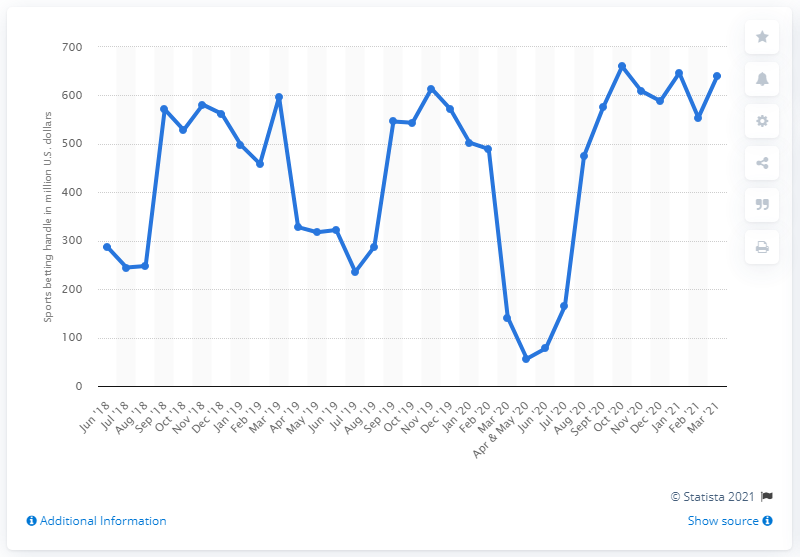Identify some key points in this picture. In March 2021, the total amount of money wagered on sports in Nevada was approximately $640.98 million. 